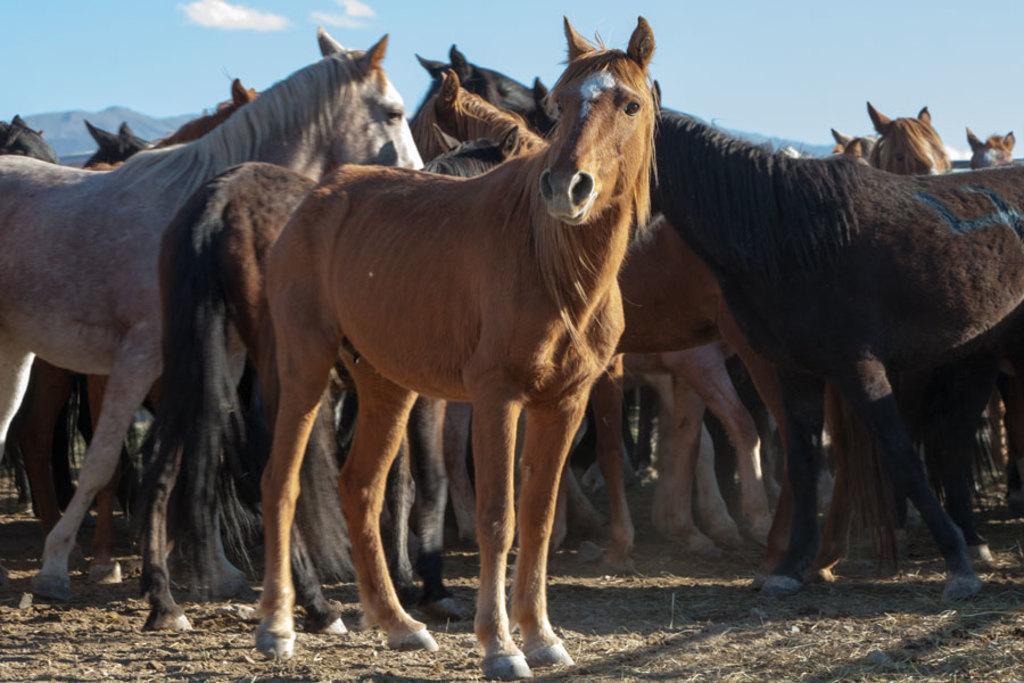Please provide a concise description of this image. In the image I can see some horses on the ground. 